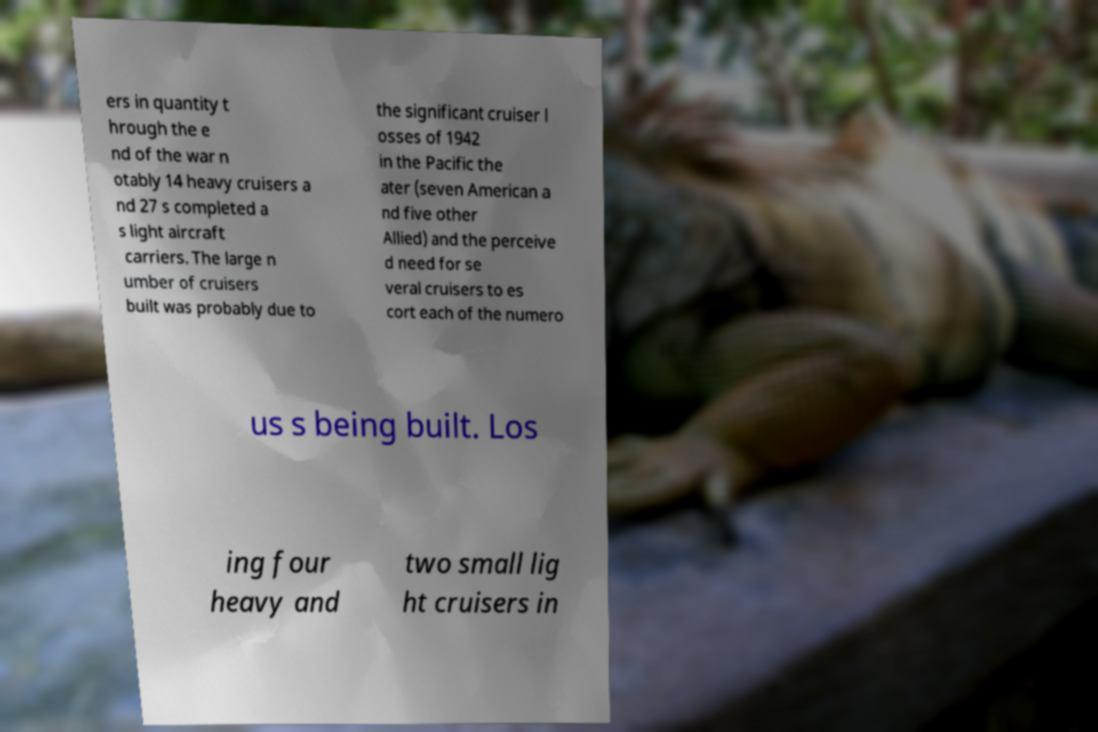Please identify and transcribe the text found in this image. ers in quantity t hrough the e nd of the war n otably 14 heavy cruisers a nd 27 s completed a s light aircraft carriers. The large n umber of cruisers built was probably due to the significant cruiser l osses of 1942 in the Pacific the ater (seven American a nd five other Allied) and the perceive d need for se veral cruisers to es cort each of the numero us s being built. Los ing four heavy and two small lig ht cruisers in 